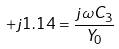<formula> <loc_0><loc_0><loc_500><loc_500>+ j 1 . 1 4 = \frac { j \omega C _ { 3 } } { Y _ { 0 } }</formula> 